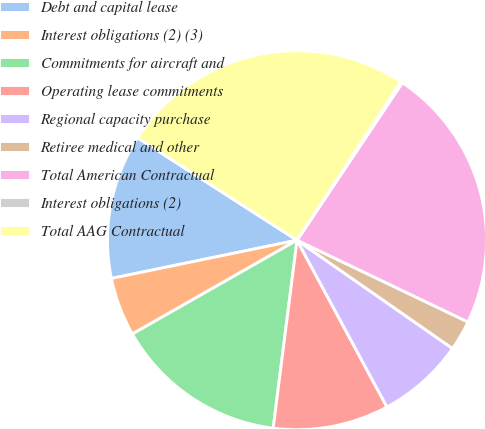Convert chart. <chart><loc_0><loc_0><loc_500><loc_500><pie_chart><fcel>Debt and capital lease<fcel>Interest obligations (2) (3)<fcel>Commitments for aircraft and<fcel>Operating lease commitments<fcel>Regional capacity purchase<fcel>Retiree medical and other<fcel>Total American Contractual<fcel>Interest obligations (2)<fcel>Total AAG Contractual<nl><fcel>12.32%<fcel>5.01%<fcel>14.75%<fcel>9.88%<fcel>7.45%<fcel>2.58%<fcel>22.72%<fcel>0.15%<fcel>25.15%<nl></chart> 